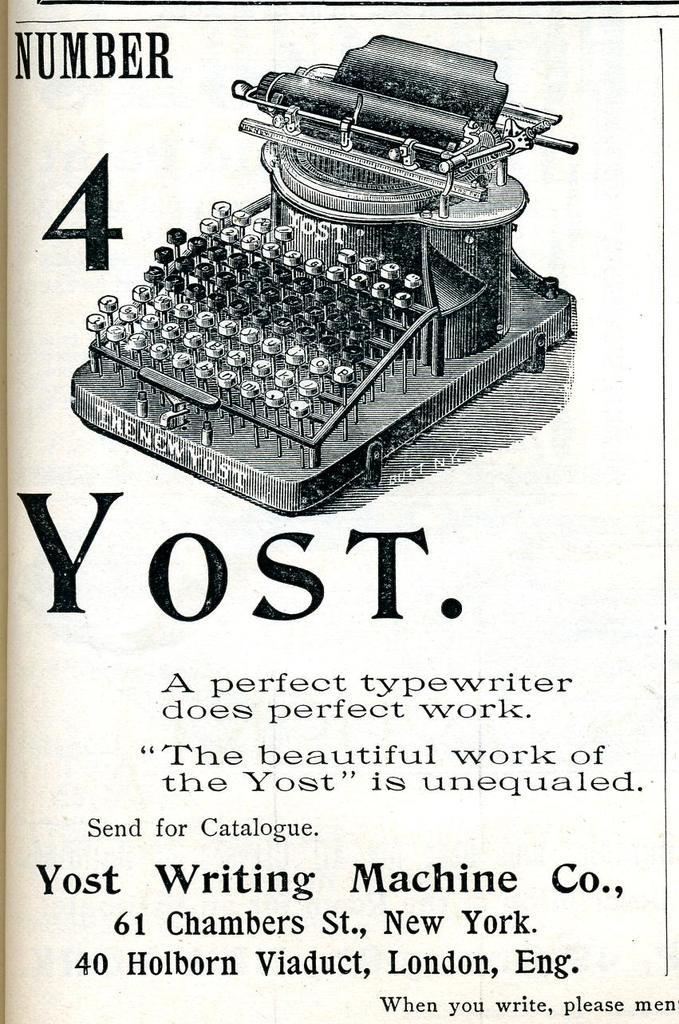Provide a one-sentence caption for the provided image. An old page containing information on a Number 4 Yost typewriter. 